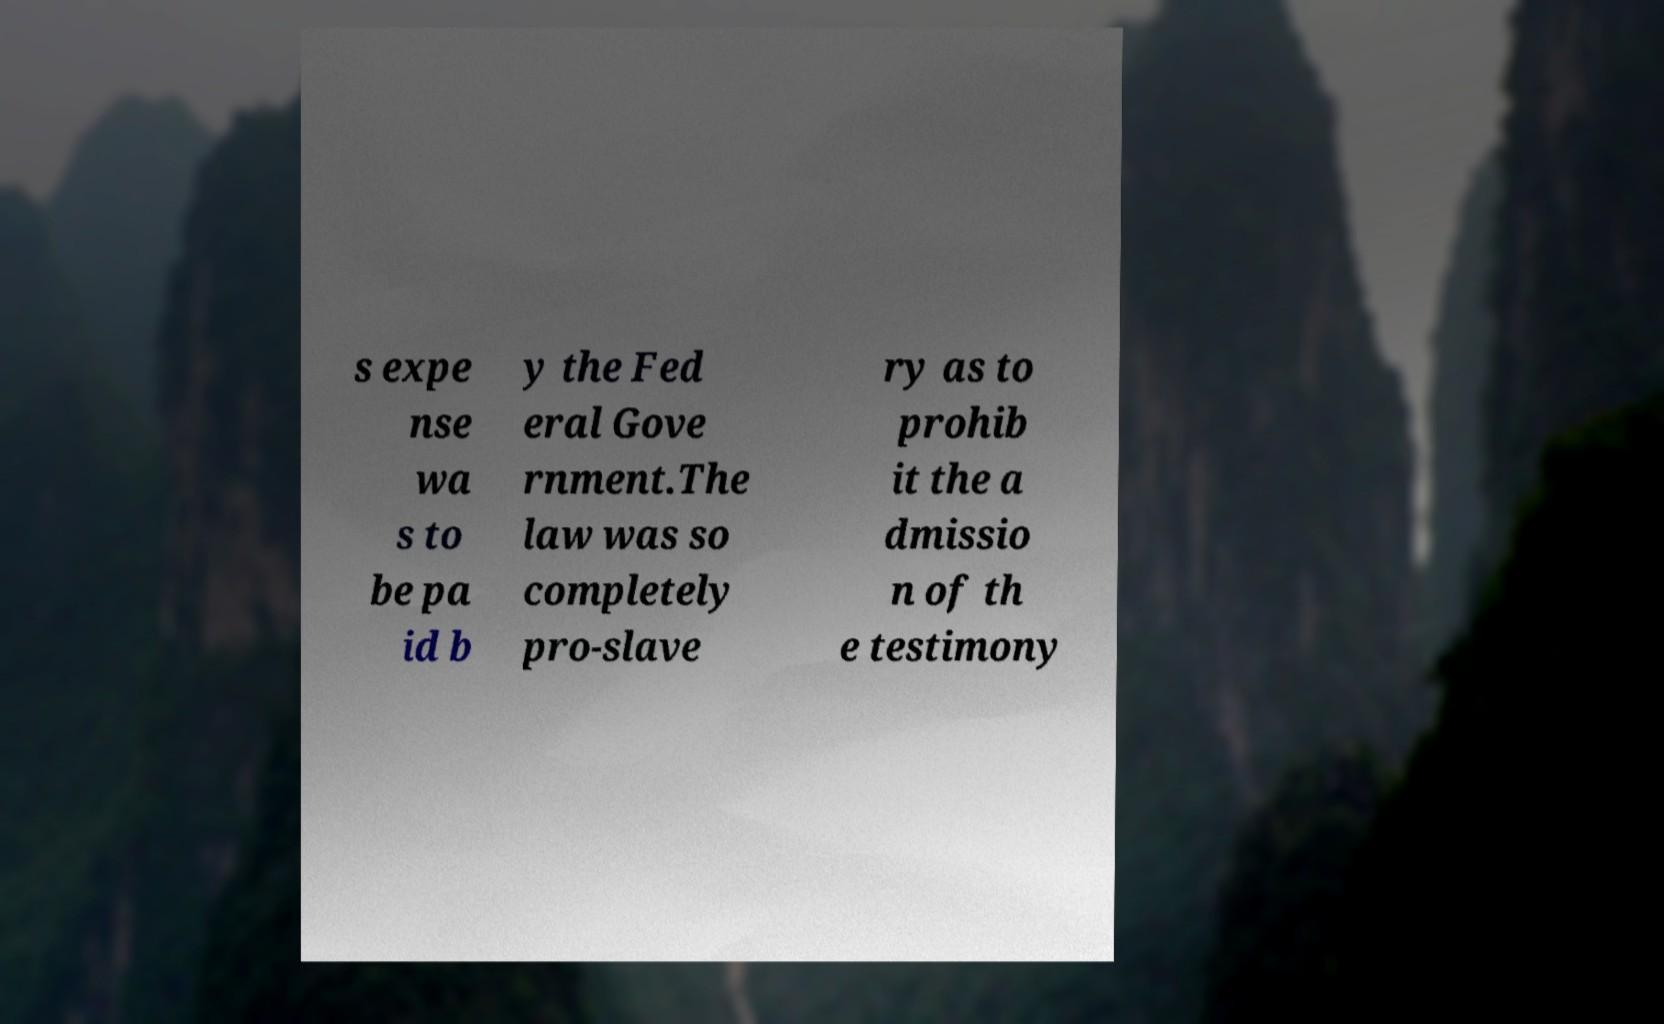Can you read and provide the text displayed in the image?This photo seems to have some interesting text. Can you extract and type it out for me? s expe nse wa s to be pa id b y the Fed eral Gove rnment.The law was so completely pro-slave ry as to prohib it the a dmissio n of th e testimony 